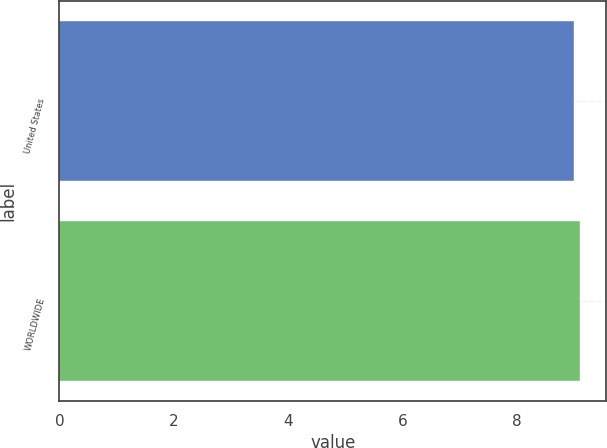<chart> <loc_0><loc_0><loc_500><loc_500><bar_chart><fcel>United States<fcel>WORLDWIDE<nl><fcel>9<fcel>9.1<nl></chart> 